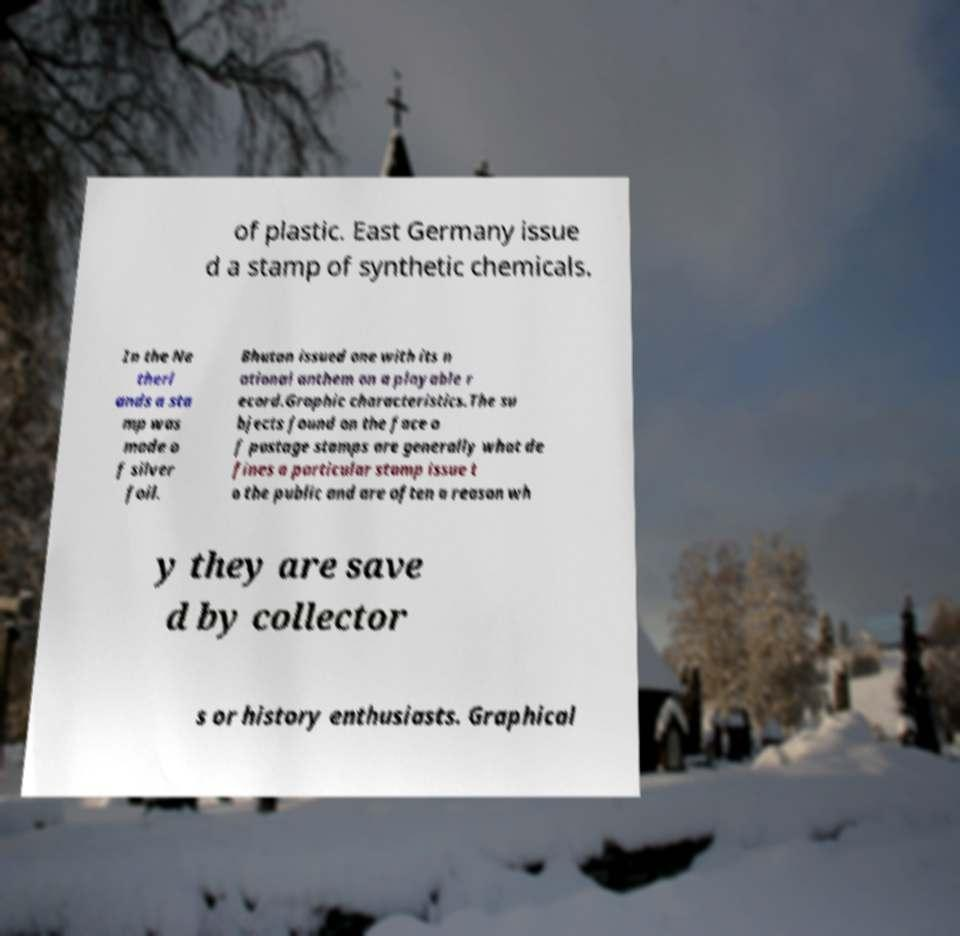Please identify and transcribe the text found in this image. of plastic. East Germany issue d a stamp of synthetic chemicals. In the Ne therl ands a sta mp was made o f silver foil. Bhutan issued one with its n ational anthem on a playable r ecord.Graphic characteristics.The su bjects found on the face o f postage stamps are generally what de fines a particular stamp issue t o the public and are often a reason wh y they are save d by collector s or history enthusiasts. Graphical 